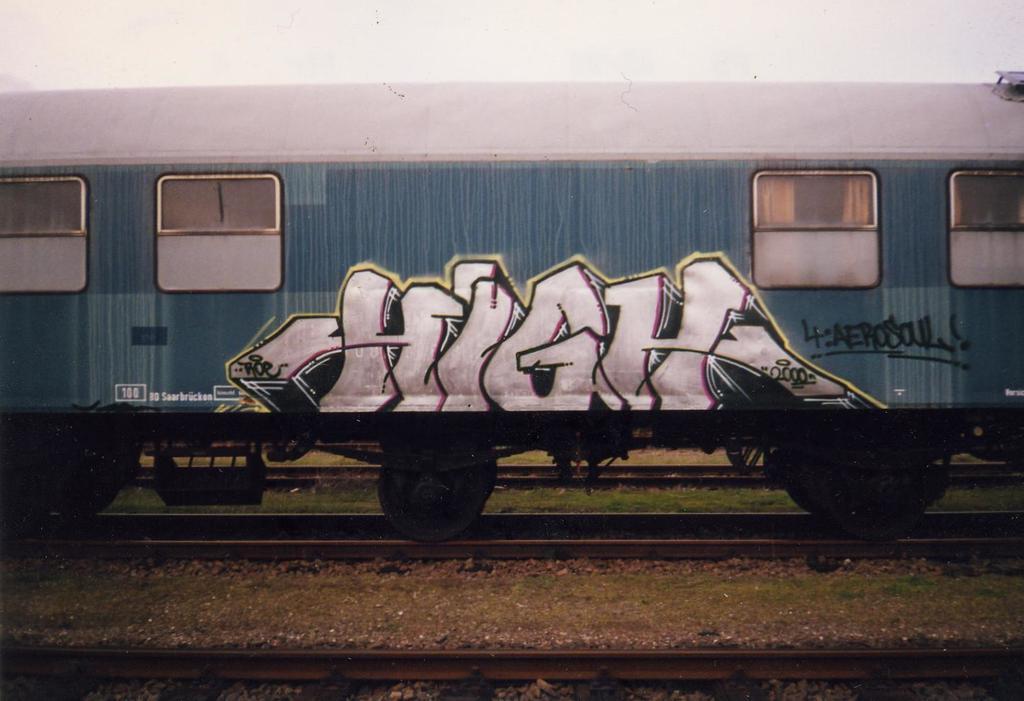How many wheels does this train have?
Offer a very short reply. 6. What' the graffiti tag read?
Provide a succinct answer. High. 